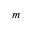Convert formula to latex. <formula><loc_0><loc_0><loc_500><loc_500>m</formula> 